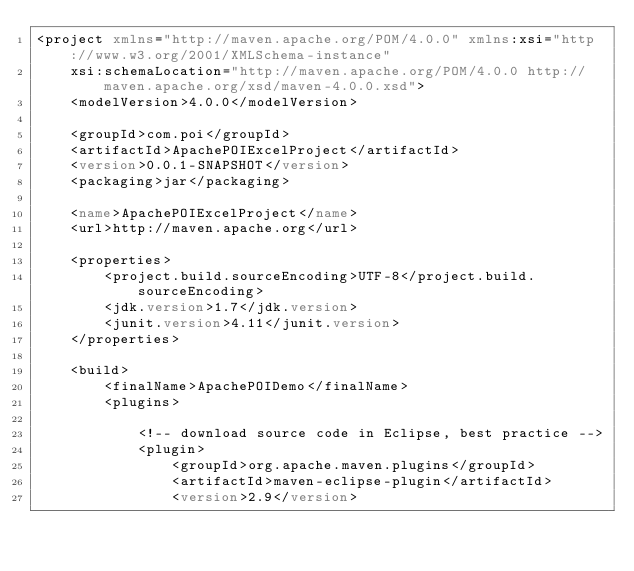<code> <loc_0><loc_0><loc_500><loc_500><_XML_><project xmlns="http://maven.apache.org/POM/4.0.0" xmlns:xsi="http://www.w3.org/2001/XMLSchema-instance"
	xsi:schemaLocation="http://maven.apache.org/POM/4.0.0 http://maven.apache.org/xsd/maven-4.0.0.xsd">
	<modelVersion>4.0.0</modelVersion>

	<groupId>com.poi</groupId>
	<artifactId>ApachePOIExcelProject</artifactId>
	<version>0.0.1-SNAPSHOT</version>
	<packaging>jar</packaging>

	<name>ApachePOIExcelProject</name>
	<url>http://maven.apache.org</url>

	<properties>
		<project.build.sourceEncoding>UTF-8</project.build.sourceEncoding>
		<jdk.version>1.7</jdk.version>
		<junit.version>4.11</junit.version>
	</properties>

	<build>
		<finalName>ApachePOIDemo</finalName>
		<plugins>

			<!-- download source code in Eclipse, best practice -->
			<plugin>
				<groupId>org.apache.maven.plugins</groupId>
				<artifactId>maven-eclipse-plugin</artifactId>
				<version>2.9</version></code> 